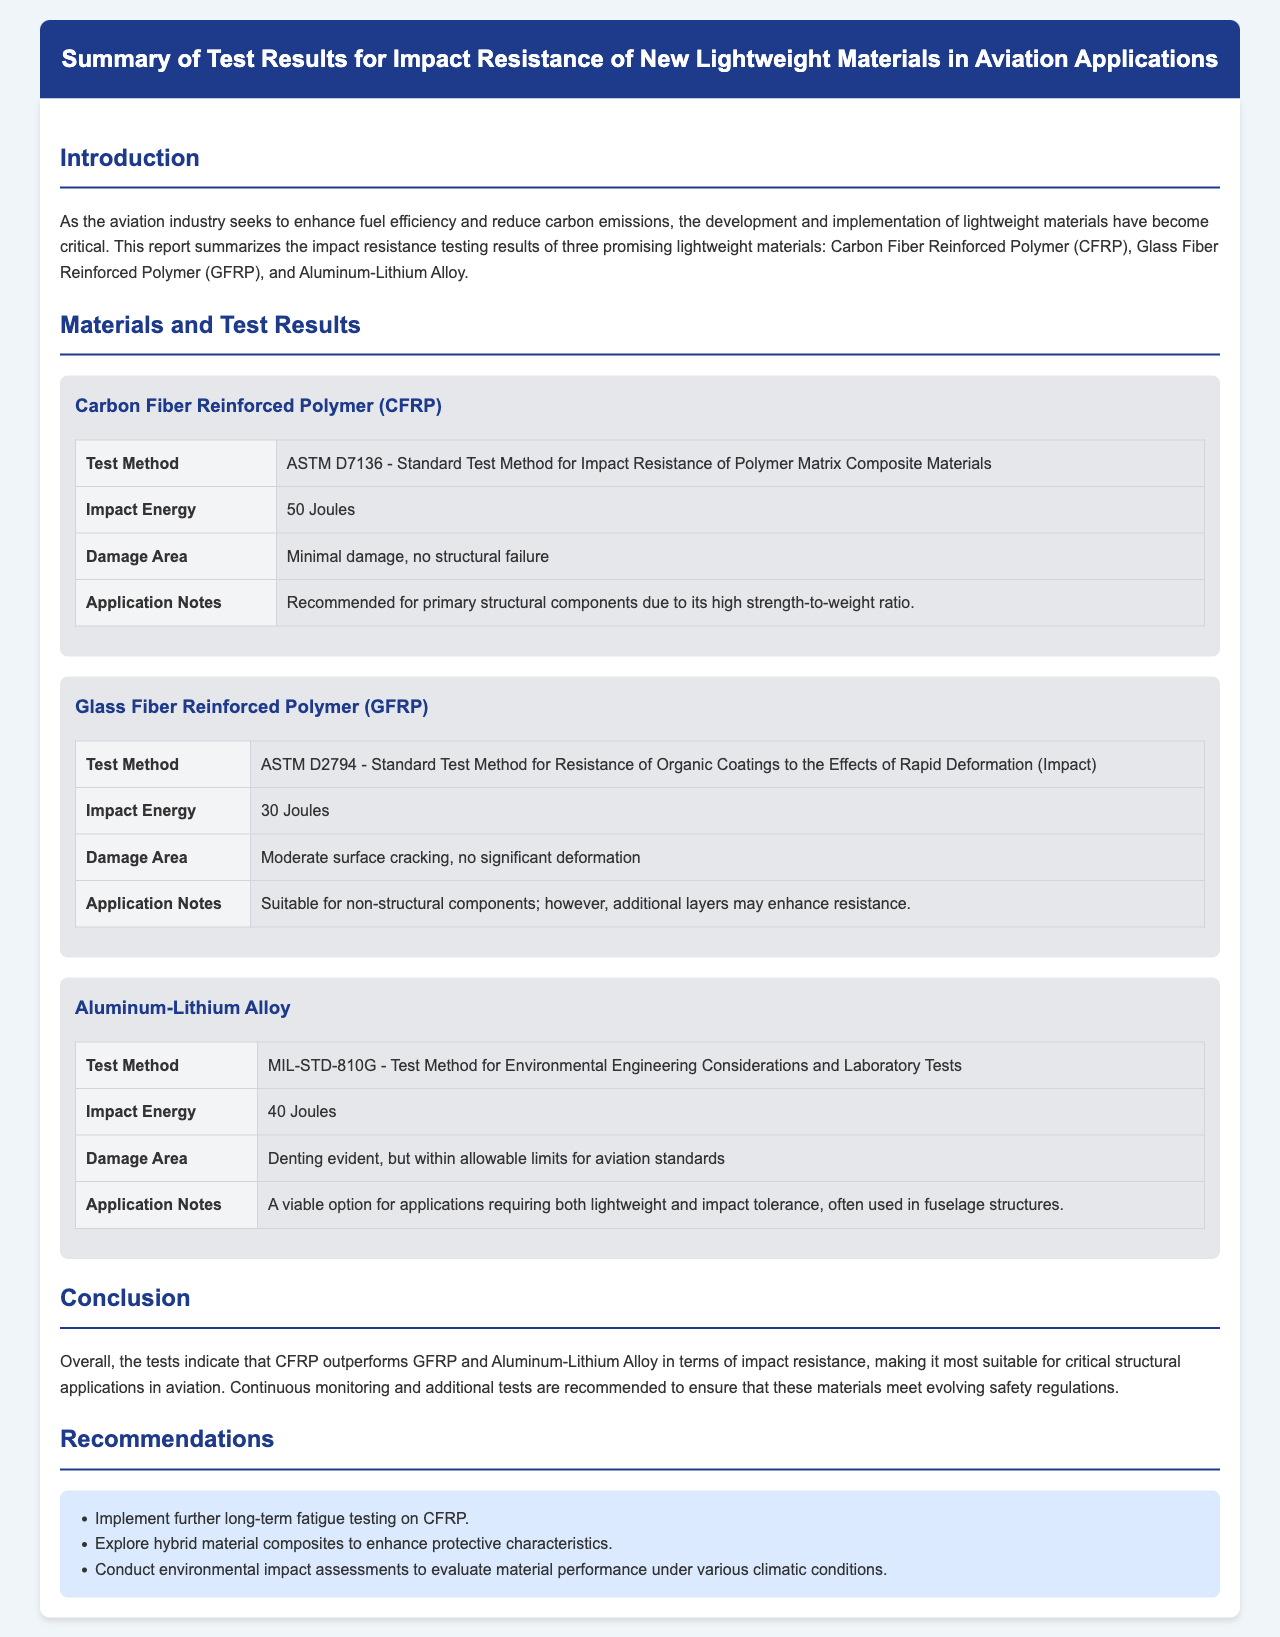what is the title of the report? The title of the report is stated at the top of the document.
Answer: Summary of Test Results for Impact Resistance of New Lightweight Materials in Aviation Applications how many lightweight materials are tested in the report? The report summarizes the test results of three materials as mentioned in the introduction section.
Answer: three what is the impact energy for Carbon Fiber Reinforced Polymer (CFRP)? The specific impact energy for CFRP can be found in its test results section.
Answer: 50 Joules what was the damage area observed in the GFRP testing? The damage area for GFRP is described in the corresponding section.
Answer: Moderate surface cracking, no significant deformation which material showed minimal damage during testing? The testing results relate minimal damage to one specific lightweight material mentioned in the document.
Answer: Carbon Fiber Reinforced Polymer (CFRP) what is recommended for CFRP in the report? The recommendations regarding CFRP are listed in the recommendations section of the report.
Answer: Implement further long-term fatigue testing on CFRP what test method was used for Aluminum-Lithium Alloy? The test method for Aluminum-Lithium Alloy is provided within its material section.
Answer: MIL-STD-810G which material is deemed suitable for non-structural components? The suitability of materials for specific applications is discussed; one material is explicitly mentioned here.
Answer: Glass Fiber Reinforced Polymer (GFRP) what does the conclusion say about CFRP's performance? The conclusion draws attention to CFRP’s comparative performance as stated in the report.
Answer: CFRP outperforms GFRP and Aluminum-Lithium Alloy in terms of impact resistance 